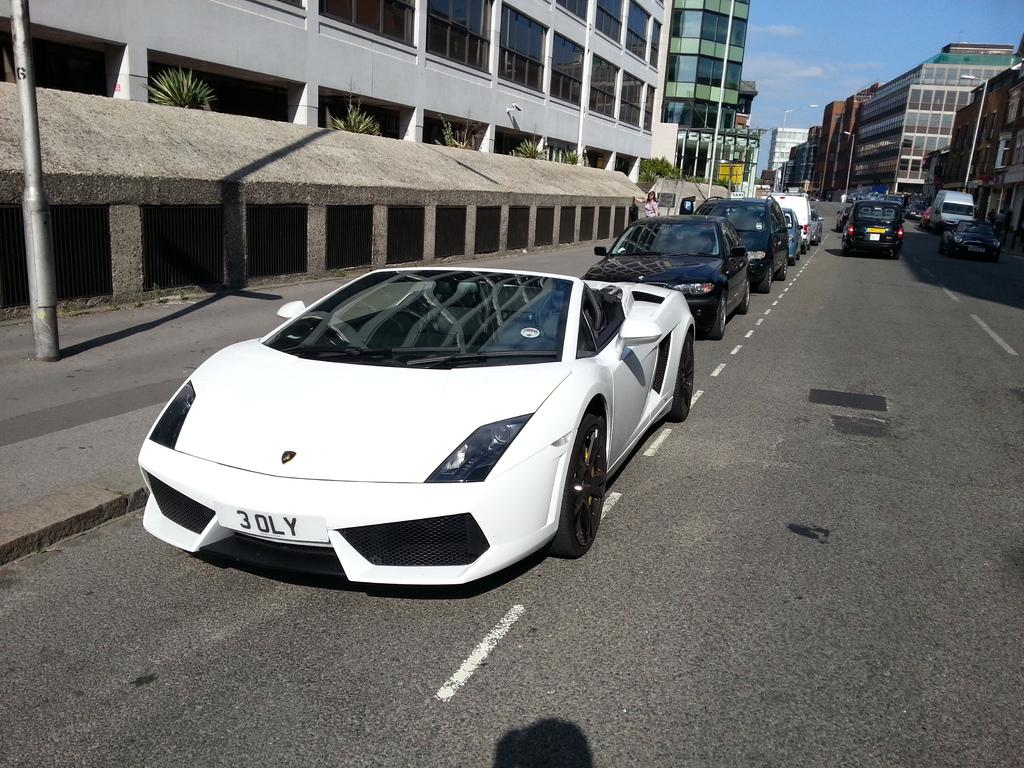What type of vehicles can be seen on the road in the image? There are cars on the road in the image. What structures are visible in the image? There are buildings visible in the image. What part of the natural environment is visible in the image? The sky is visible in the background of the image. What type of sweater is being worn by the building in the image? There is no sweater present in the image, as buildings do not wear clothing. Can you solve the riddle that is depicted in the image? There is no riddle present in the image, so it cannot be solved. 